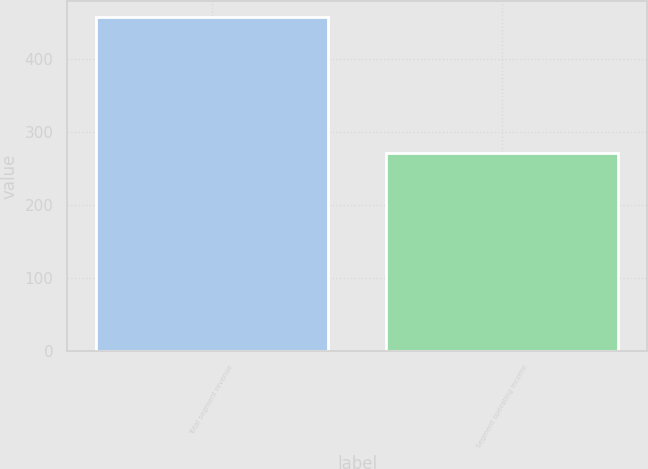<chart> <loc_0><loc_0><loc_500><loc_500><bar_chart><fcel>Total segment revenue<fcel>Segment operating income<nl><fcel>457<fcel>271<nl></chart> 